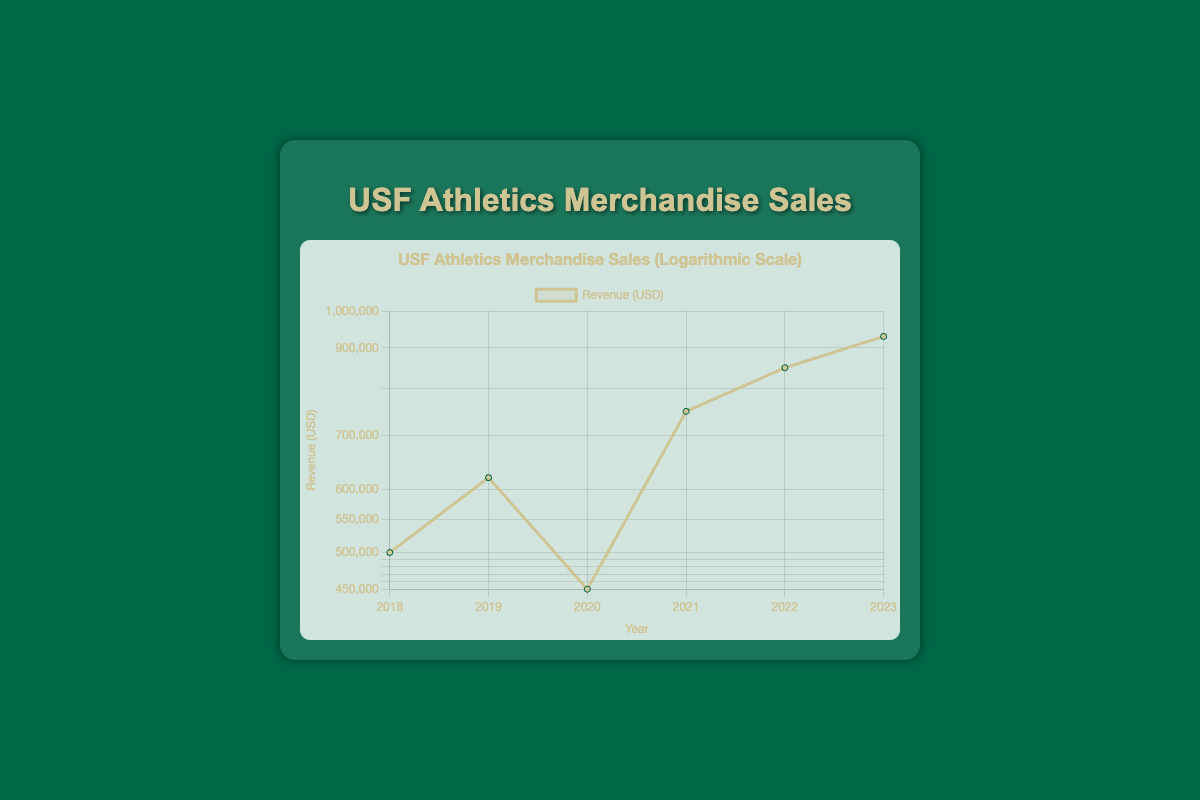What was the revenue generated in 2020? The table shows that in the year 2020, the revenue generated from merchandise sales was 450000 USD.
Answer: 450000 Which year saw the highest revenue from merchandise sales? According to the table, the highest revenue was in 2023, with 930000 USD generated from merchandise sales.
Answer: 2023 What is the difference in revenue between 2018 and 2022? The revenue in 2018 was 500000 USD and in 2022 it was 850000 USD. The difference is 850000 - 500000 = 350000 USD.
Answer: 350000 Did the revenue increase from 2019 to 2020? The revenue in 2019 was 620000 USD and in 2020 it was 450000 USD. Since 450000 is less than 620000, the revenue did decrease during that period.
Answer: No What was the average revenue generated over the six years presented in the table? To find the average revenue, calculate the total revenue for all years: 500000 + 620000 + 450000 + 750000 + 850000 + 930000 = 3200000 USD. Then, divide this total by the number of years, which is 6: 3200000 / 6 = 533333.33 USD.
Answer: 533333.33 In which year was the revenue less than 600000 USD? Looking at the table, the only year where the revenue was less than 600000 USD is 2018 (500000 USD) and 2020 (450000 USD).
Answer: 2018, 2020 What trend can be observed in the merchandise sales revenue from 2018 to 2023? Observing the data from the table, it can be seen that the revenue increased over time each year except for a decrease from 2019 to 2020.
Answer: Increasing overall with one decrease What is the total revenue generated from 2018 to 2023? Adding up all the annual revenues: 500000 + 620000 + 450000 + 750000 + 850000 + 930000 gives us a total of 3200000 USD generated from merchandise sales over these six years.
Answer: 3200000 